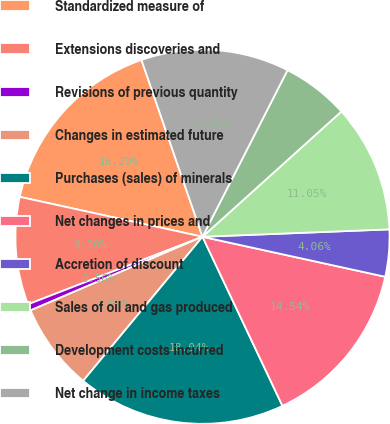Convert chart to OTSL. <chart><loc_0><loc_0><loc_500><loc_500><pie_chart><fcel>Standardized measure of<fcel>Extensions discoveries and<fcel>Revisions of previous quantity<fcel>Changes in estimated future<fcel>Purchases (sales) of minerals<fcel>Net changes in prices and<fcel>Accretion of discount<fcel>Sales of oil and gas produced<fcel>Development costs incurred<fcel>Net change in income taxes<nl><fcel>16.29%<fcel>9.3%<fcel>0.56%<fcel>7.55%<fcel>18.04%<fcel>14.54%<fcel>4.06%<fcel>11.05%<fcel>5.81%<fcel>12.8%<nl></chart> 